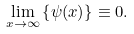Convert formula to latex. <formula><loc_0><loc_0><loc_500><loc_500>\lim _ { x \to \infty } \left \{ \psi ( x ) \right \} \equiv 0 .</formula> 